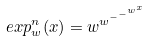<formula> <loc_0><loc_0><loc_500><loc_500>e x p _ { w } ^ { n } ( x ) = w ^ { w ^ { - ^ { - ^ { w ^ { x } } } } }</formula> 